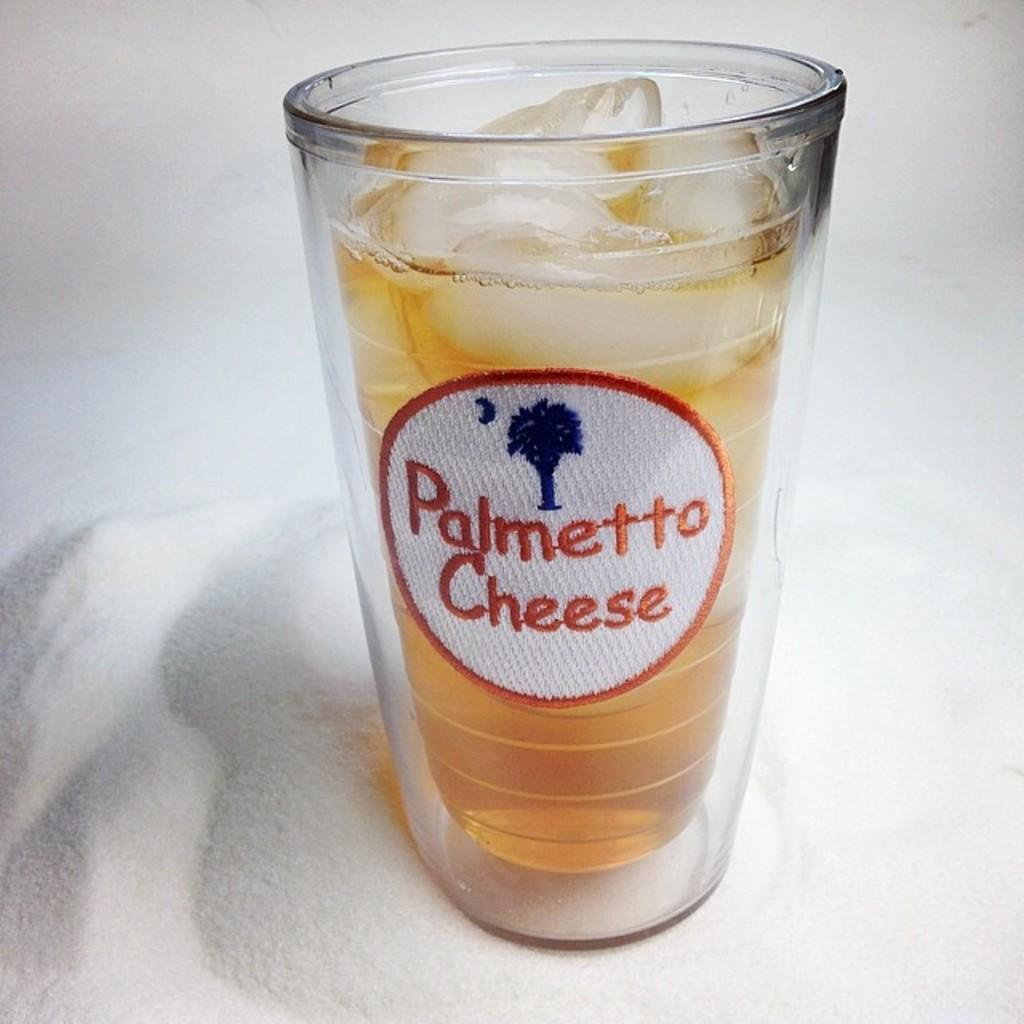What is in the glass that is visible in the image? The wine glass contains wine and ice. Where is the wine glass located in the image? The wine glass is placed on a table. What type of clouds can be seen in the image? There are no clouds visible in the image; it only features a wine glass with wine and ice on a table. 